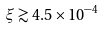<formula> <loc_0><loc_0><loc_500><loc_500>\xi \gtrsim 4 . 5 \times 1 0 ^ { - 4 }</formula> 